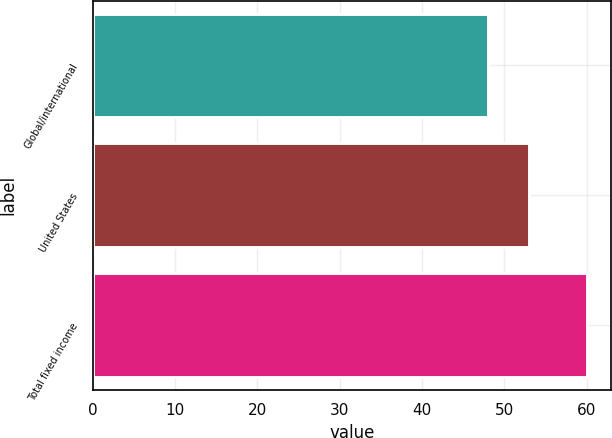Convert chart to OTSL. <chart><loc_0><loc_0><loc_500><loc_500><bar_chart><fcel>Global/international<fcel>United States<fcel>Total fixed income<nl><fcel>48<fcel>53<fcel>60<nl></chart> 